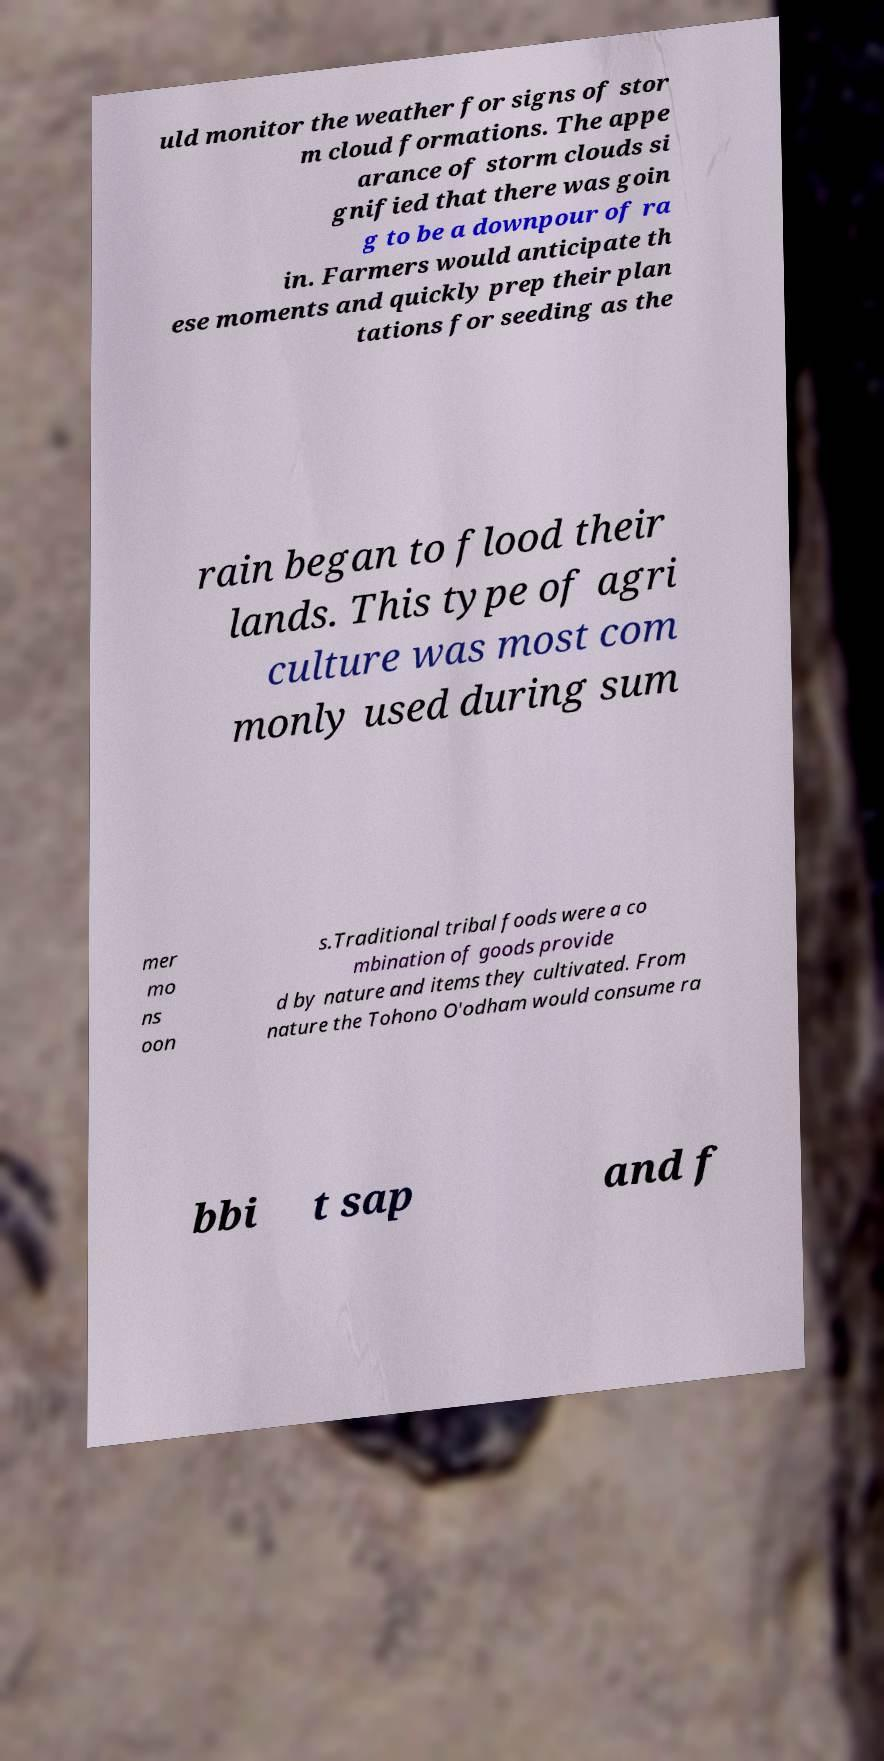Please identify and transcribe the text found in this image. uld monitor the weather for signs of stor m cloud formations. The appe arance of storm clouds si gnified that there was goin g to be a downpour of ra in. Farmers would anticipate th ese moments and quickly prep their plan tations for seeding as the rain began to flood their lands. This type of agri culture was most com monly used during sum mer mo ns oon s.Traditional tribal foods were a co mbination of goods provide d by nature and items they cultivated. From nature the Tohono O'odham would consume ra bbi t sap and f 